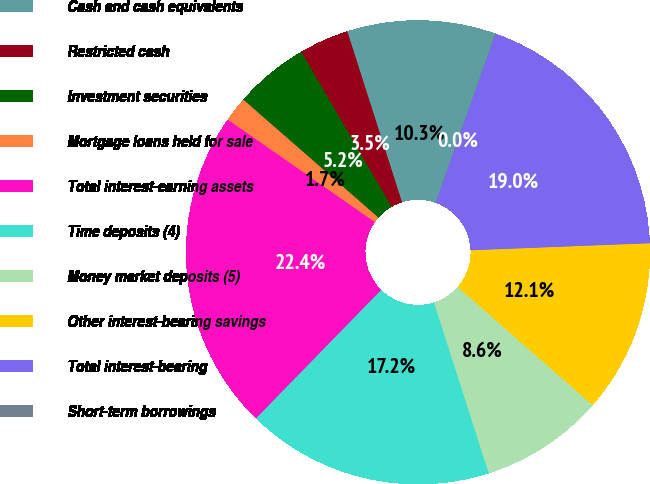<chart> <loc_0><loc_0><loc_500><loc_500><pie_chart><fcel>Cash and cash equivalents<fcel>Restricted cash<fcel>Investment securities<fcel>Mortgage loans held for sale<fcel>Total interest-earning assets<fcel>Time deposits (4)<fcel>Money market deposits (5)<fcel>Other interest-bearing savings<fcel>Total interest-bearing<fcel>Short-term borrowings<nl><fcel>10.34%<fcel>3.46%<fcel>5.18%<fcel>1.74%<fcel>22.39%<fcel>17.23%<fcel>8.62%<fcel>12.07%<fcel>18.95%<fcel>0.02%<nl></chart> 